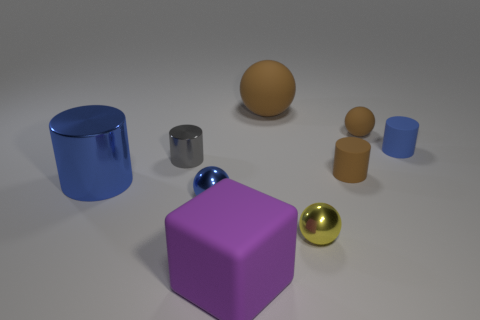Add 1 tiny yellow blocks. How many objects exist? 10 Subtract all cylinders. How many objects are left? 5 Add 5 big purple things. How many big purple things exist? 6 Subtract 0 red blocks. How many objects are left? 9 Subtract all small gray cylinders. Subtract all red metallic objects. How many objects are left? 8 Add 4 big rubber spheres. How many big rubber spheres are left? 5 